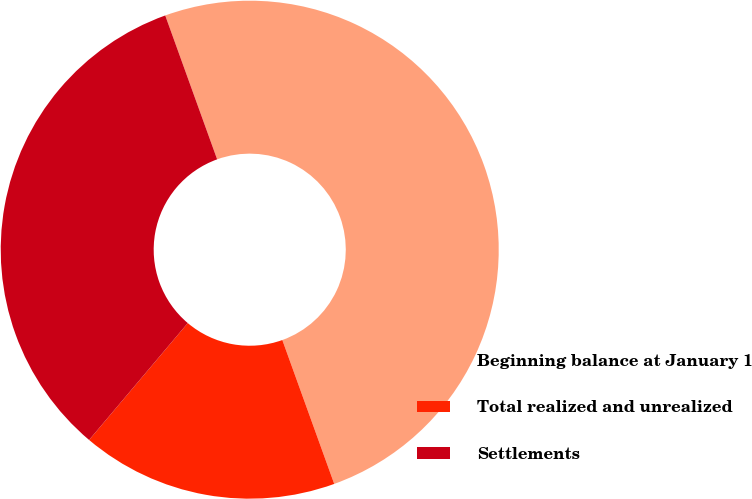<chart> <loc_0><loc_0><loc_500><loc_500><pie_chart><fcel>Beginning balance at January 1<fcel>Total realized and unrealized<fcel>Settlements<nl><fcel>50.0%<fcel>16.67%<fcel>33.33%<nl></chart> 